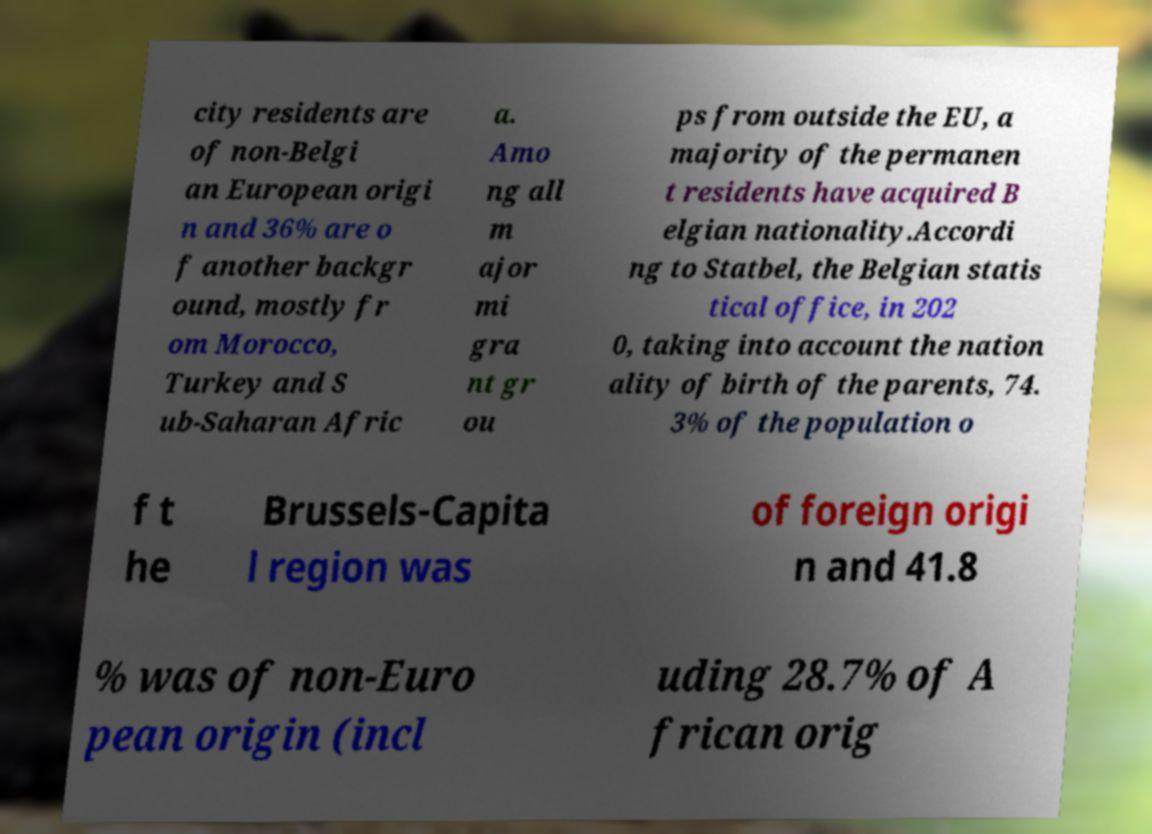Could you assist in decoding the text presented in this image and type it out clearly? city residents are of non-Belgi an European origi n and 36% are o f another backgr ound, mostly fr om Morocco, Turkey and S ub-Saharan Afric a. Amo ng all m ajor mi gra nt gr ou ps from outside the EU, a majority of the permanen t residents have acquired B elgian nationality.Accordi ng to Statbel, the Belgian statis tical office, in 202 0, taking into account the nation ality of birth of the parents, 74. 3% of the population o f t he Brussels-Capita l region was of foreign origi n and 41.8 % was of non-Euro pean origin (incl uding 28.7% of A frican orig 